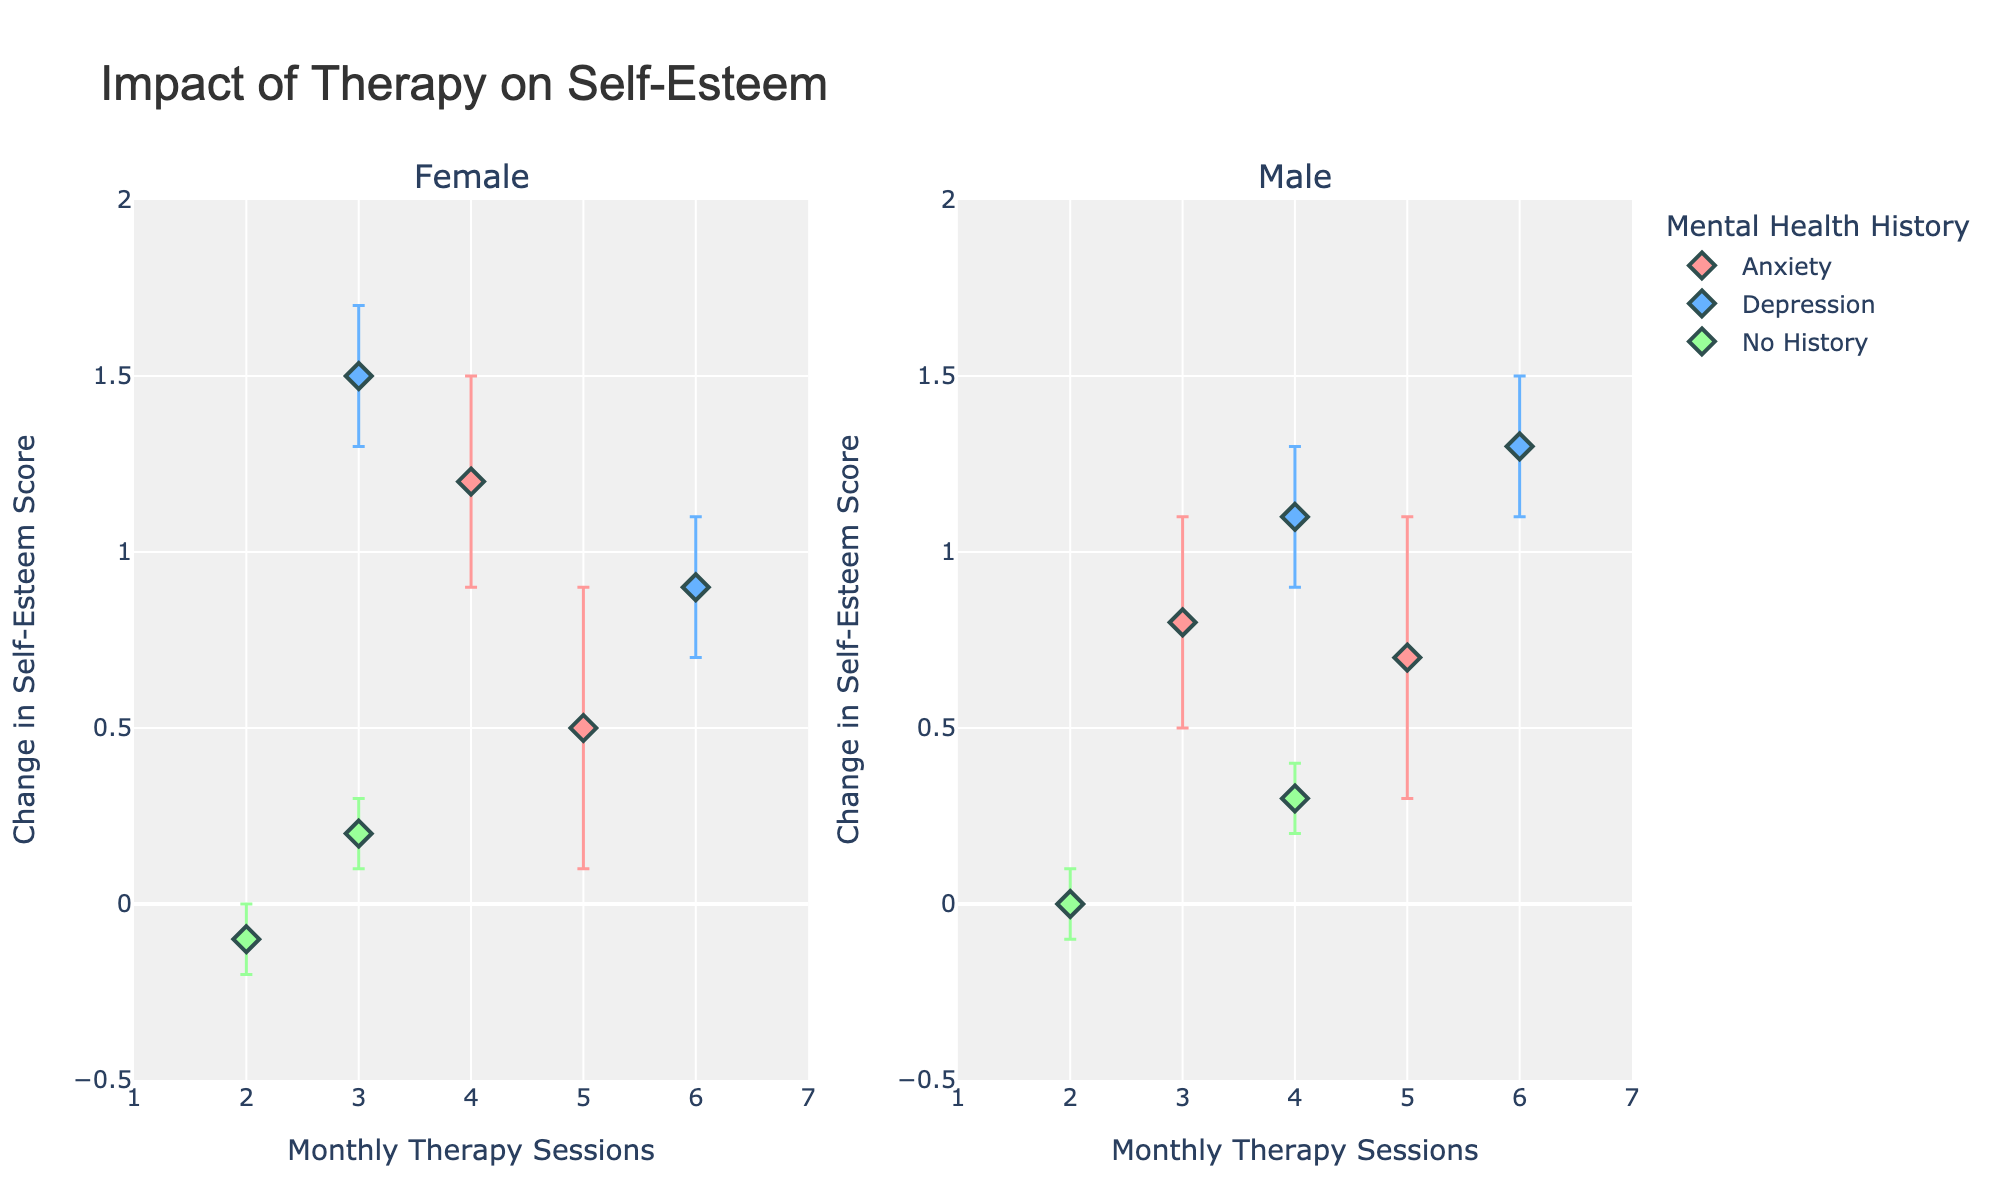How many data points are plotted on the graph for females with anxiety? Look at the scatter plot for females and identify the points with the color that represents anxiety. Count these points.
Answer: 2 What is the title of the graph? The title is usually given at the top of the chart. It’s clearly labeled to indicate what the graph is about.
Answer: Impact of Therapy on Self-Esteem What is the lowest change in self-esteem score observed, and for which group is it? Look at the y-axis for the lowest point. Then, check the color and subplot (Female or Male) to identify which group it belongs to.
Answer: -0.1 for Females with No History Which group shows the largest positive change in self-esteem score, and what is the value? Identify the highest point on the y-axis for both subplots. Check the color and the value of the data point.
Answer: 1.5 for Females with Depression How many therapy sessions correspond to the largest error margin for females with anxiety? Look at the subplot for females, find the points associated with anxiety, and compare the error bars to find the largest one. Note the x-axis value.
Answer: 5 For males with no history of mental health issues, how does the change in self-esteem score compare between 2 and 4 therapy sessions? Look at the subplot for males. Identify the data points for 'No History' for 2 and 4 therapy sessions and compare their change in self-esteem scores.
Answer: 0.0 (2 sessions) is lower than 0.3 (4 sessions) What is the error margin for the female with depression undergoing 3 therapy sessions? Find the relevant data point in the female subplot for depression and note the error margin shown by the error bar.
Answer: 0.2 Between males and females, which gender shows more variable self-esteem changes with therapy sessions? Compare the spread and error bars magnitude on both subplots. Look for more variation in the data points.
Answer: Females 